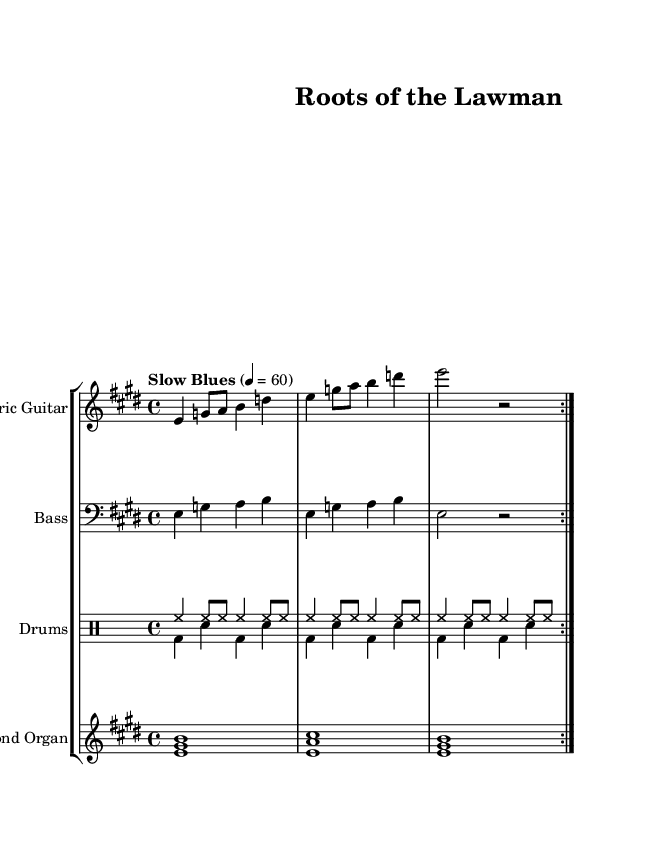What is the key signature of this music? The key signature is E major, which has four sharps (F#, C#, G#, D#). You can identify the key signature by looking at the beginning of the staff where the sharps are notated.
Answer: E major What is the time signature of the piece? The time signature is 4/4, indicated at the beginning of the score. This means there are four beats per measure, and a quarter note receives one beat.
Answer: 4/4 What is the tempo marking of the music? The tempo marking indicates "Slow Blues," which is shown above the staff in the score. This description signifies the feel of the performance, suggesting a laid-back yet rhythmic approach typical for blues music.
Answer: Slow Blues How many measures are repeated in the electric guitar part? The electric guitar part contains a repeating section, as indicated by the "repeat volta" symbol. The repeated portion has two measures that are specified within the repetition sign.
Answer: 2 measures What type of organ is featured in this piece? The score mentions a "Hammond Organ," which is known for its role in blues and jazz music. This is identified in the staff label that names the instrument specifically.
Answer: Hammond Organ How many different drum voices are utilized? The piece uses two different drum voices as indicated by the "DrumVoice" labels in the drum staff. The distinct parts are called up to play different rhythms or patterns simultaneously.
Answer: 2 voices What is the dominant note or chord used in the harmony section? The dominant chord is represented by the repetition of the notes E, G#, and B in the Hammond Organ part. This can be identified by looking at the specific chords written above the staff.
Answer: E major chord 